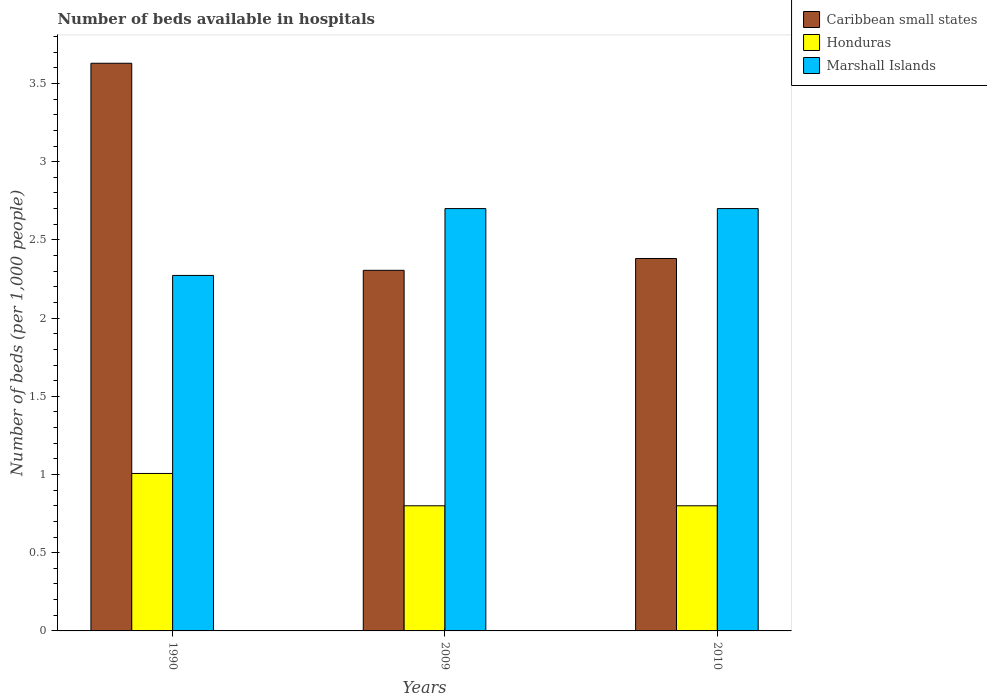How many different coloured bars are there?
Provide a short and direct response. 3. Are the number of bars per tick equal to the number of legend labels?
Offer a very short reply. Yes. How many bars are there on the 2nd tick from the left?
Keep it short and to the point. 3. How many bars are there on the 2nd tick from the right?
Offer a very short reply. 3. What is the label of the 1st group of bars from the left?
Make the answer very short. 1990. What is the number of beds in the hospiatls of in Honduras in 2010?
Give a very brief answer. 0.8. Across all years, what is the maximum number of beds in the hospiatls of in Marshall Islands?
Offer a very short reply. 2.7. Across all years, what is the minimum number of beds in the hospiatls of in Marshall Islands?
Keep it short and to the point. 2.27. What is the total number of beds in the hospiatls of in Marshall Islands in the graph?
Give a very brief answer. 7.67. What is the difference between the number of beds in the hospiatls of in Marshall Islands in 1990 and that in 2010?
Provide a short and direct response. -0.43. What is the difference between the number of beds in the hospiatls of in Marshall Islands in 2010 and the number of beds in the hospiatls of in Honduras in 2009?
Provide a succinct answer. 1.9. What is the average number of beds in the hospiatls of in Caribbean small states per year?
Keep it short and to the point. 2.77. In the year 1990, what is the difference between the number of beds in the hospiatls of in Marshall Islands and number of beds in the hospiatls of in Honduras?
Offer a terse response. 1.27. In how many years, is the number of beds in the hospiatls of in Marshall Islands greater than 0.7?
Your answer should be compact. 3. What is the ratio of the number of beds in the hospiatls of in Caribbean small states in 2009 to that in 2010?
Provide a succinct answer. 0.97. Is the number of beds in the hospiatls of in Marshall Islands in 1990 less than that in 2009?
Your answer should be very brief. Yes. Is the difference between the number of beds in the hospiatls of in Marshall Islands in 1990 and 2010 greater than the difference between the number of beds in the hospiatls of in Honduras in 1990 and 2010?
Give a very brief answer. No. What is the difference between the highest and the lowest number of beds in the hospiatls of in Caribbean small states?
Your response must be concise. 1.32. What does the 3rd bar from the left in 2010 represents?
Ensure brevity in your answer.  Marshall Islands. What does the 1st bar from the right in 2010 represents?
Your response must be concise. Marshall Islands. What is the difference between two consecutive major ticks on the Y-axis?
Ensure brevity in your answer.  0.5. Does the graph contain any zero values?
Offer a very short reply. No. Does the graph contain grids?
Ensure brevity in your answer.  No. Where does the legend appear in the graph?
Make the answer very short. Top right. How are the legend labels stacked?
Provide a short and direct response. Vertical. What is the title of the graph?
Make the answer very short. Number of beds available in hospitals. Does "Liberia" appear as one of the legend labels in the graph?
Give a very brief answer. No. What is the label or title of the Y-axis?
Provide a succinct answer. Number of beds (per 1,0 people). What is the Number of beds (per 1,000 people) in Caribbean small states in 1990?
Provide a succinct answer. 3.63. What is the Number of beds (per 1,000 people) of Honduras in 1990?
Provide a succinct answer. 1.01. What is the Number of beds (per 1,000 people) in Marshall Islands in 1990?
Provide a succinct answer. 2.27. What is the Number of beds (per 1,000 people) of Caribbean small states in 2009?
Your answer should be compact. 2.31. What is the Number of beds (per 1,000 people) of Honduras in 2009?
Your response must be concise. 0.8. What is the Number of beds (per 1,000 people) of Caribbean small states in 2010?
Offer a very short reply. 2.38. What is the Number of beds (per 1,000 people) of Honduras in 2010?
Make the answer very short. 0.8. What is the Number of beds (per 1,000 people) of Marshall Islands in 2010?
Your response must be concise. 2.7. Across all years, what is the maximum Number of beds (per 1,000 people) of Caribbean small states?
Ensure brevity in your answer.  3.63. Across all years, what is the maximum Number of beds (per 1,000 people) in Honduras?
Ensure brevity in your answer.  1.01. Across all years, what is the minimum Number of beds (per 1,000 people) in Caribbean small states?
Offer a terse response. 2.31. Across all years, what is the minimum Number of beds (per 1,000 people) of Marshall Islands?
Your answer should be compact. 2.27. What is the total Number of beds (per 1,000 people) of Caribbean small states in the graph?
Your response must be concise. 8.32. What is the total Number of beds (per 1,000 people) of Honduras in the graph?
Give a very brief answer. 2.61. What is the total Number of beds (per 1,000 people) of Marshall Islands in the graph?
Ensure brevity in your answer.  7.67. What is the difference between the Number of beds (per 1,000 people) in Caribbean small states in 1990 and that in 2009?
Your answer should be very brief. 1.32. What is the difference between the Number of beds (per 1,000 people) in Honduras in 1990 and that in 2009?
Make the answer very short. 0.21. What is the difference between the Number of beds (per 1,000 people) of Marshall Islands in 1990 and that in 2009?
Offer a very short reply. -0.43. What is the difference between the Number of beds (per 1,000 people) of Caribbean small states in 1990 and that in 2010?
Offer a very short reply. 1.25. What is the difference between the Number of beds (per 1,000 people) of Honduras in 1990 and that in 2010?
Make the answer very short. 0.21. What is the difference between the Number of beds (per 1,000 people) in Marshall Islands in 1990 and that in 2010?
Ensure brevity in your answer.  -0.43. What is the difference between the Number of beds (per 1,000 people) of Caribbean small states in 2009 and that in 2010?
Provide a short and direct response. -0.08. What is the difference between the Number of beds (per 1,000 people) of Caribbean small states in 1990 and the Number of beds (per 1,000 people) of Honduras in 2009?
Your answer should be very brief. 2.83. What is the difference between the Number of beds (per 1,000 people) in Caribbean small states in 1990 and the Number of beds (per 1,000 people) in Marshall Islands in 2009?
Your answer should be compact. 0.93. What is the difference between the Number of beds (per 1,000 people) in Honduras in 1990 and the Number of beds (per 1,000 people) in Marshall Islands in 2009?
Offer a very short reply. -1.69. What is the difference between the Number of beds (per 1,000 people) in Caribbean small states in 1990 and the Number of beds (per 1,000 people) in Honduras in 2010?
Your answer should be very brief. 2.83. What is the difference between the Number of beds (per 1,000 people) of Caribbean small states in 1990 and the Number of beds (per 1,000 people) of Marshall Islands in 2010?
Your response must be concise. 0.93. What is the difference between the Number of beds (per 1,000 people) in Honduras in 1990 and the Number of beds (per 1,000 people) in Marshall Islands in 2010?
Give a very brief answer. -1.69. What is the difference between the Number of beds (per 1,000 people) in Caribbean small states in 2009 and the Number of beds (per 1,000 people) in Honduras in 2010?
Your answer should be compact. 1.51. What is the difference between the Number of beds (per 1,000 people) of Caribbean small states in 2009 and the Number of beds (per 1,000 people) of Marshall Islands in 2010?
Provide a short and direct response. -0.39. What is the difference between the Number of beds (per 1,000 people) of Honduras in 2009 and the Number of beds (per 1,000 people) of Marshall Islands in 2010?
Provide a short and direct response. -1.9. What is the average Number of beds (per 1,000 people) of Caribbean small states per year?
Offer a terse response. 2.77. What is the average Number of beds (per 1,000 people) of Honduras per year?
Offer a very short reply. 0.87. What is the average Number of beds (per 1,000 people) of Marshall Islands per year?
Your answer should be compact. 2.56. In the year 1990, what is the difference between the Number of beds (per 1,000 people) of Caribbean small states and Number of beds (per 1,000 people) of Honduras?
Your answer should be compact. 2.62. In the year 1990, what is the difference between the Number of beds (per 1,000 people) of Caribbean small states and Number of beds (per 1,000 people) of Marshall Islands?
Your response must be concise. 1.36. In the year 1990, what is the difference between the Number of beds (per 1,000 people) of Honduras and Number of beds (per 1,000 people) of Marshall Islands?
Offer a very short reply. -1.27. In the year 2009, what is the difference between the Number of beds (per 1,000 people) in Caribbean small states and Number of beds (per 1,000 people) in Honduras?
Your answer should be very brief. 1.51. In the year 2009, what is the difference between the Number of beds (per 1,000 people) of Caribbean small states and Number of beds (per 1,000 people) of Marshall Islands?
Give a very brief answer. -0.39. In the year 2009, what is the difference between the Number of beds (per 1,000 people) in Honduras and Number of beds (per 1,000 people) in Marshall Islands?
Offer a very short reply. -1.9. In the year 2010, what is the difference between the Number of beds (per 1,000 people) in Caribbean small states and Number of beds (per 1,000 people) in Honduras?
Offer a very short reply. 1.58. In the year 2010, what is the difference between the Number of beds (per 1,000 people) in Caribbean small states and Number of beds (per 1,000 people) in Marshall Islands?
Make the answer very short. -0.32. What is the ratio of the Number of beds (per 1,000 people) of Caribbean small states in 1990 to that in 2009?
Offer a terse response. 1.57. What is the ratio of the Number of beds (per 1,000 people) of Honduras in 1990 to that in 2009?
Make the answer very short. 1.26. What is the ratio of the Number of beds (per 1,000 people) of Marshall Islands in 1990 to that in 2009?
Provide a succinct answer. 0.84. What is the ratio of the Number of beds (per 1,000 people) of Caribbean small states in 1990 to that in 2010?
Give a very brief answer. 1.52. What is the ratio of the Number of beds (per 1,000 people) of Honduras in 1990 to that in 2010?
Provide a short and direct response. 1.26. What is the ratio of the Number of beds (per 1,000 people) of Marshall Islands in 1990 to that in 2010?
Your answer should be very brief. 0.84. What is the ratio of the Number of beds (per 1,000 people) in Caribbean small states in 2009 to that in 2010?
Your answer should be very brief. 0.97. What is the ratio of the Number of beds (per 1,000 people) in Honduras in 2009 to that in 2010?
Your answer should be compact. 1. What is the ratio of the Number of beds (per 1,000 people) of Marshall Islands in 2009 to that in 2010?
Offer a very short reply. 1. What is the difference between the highest and the second highest Number of beds (per 1,000 people) of Caribbean small states?
Provide a succinct answer. 1.25. What is the difference between the highest and the second highest Number of beds (per 1,000 people) in Honduras?
Provide a succinct answer. 0.21. What is the difference between the highest and the lowest Number of beds (per 1,000 people) in Caribbean small states?
Provide a succinct answer. 1.32. What is the difference between the highest and the lowest Number of beds (per 1,000 people) of Honduras?
Make the answer very short. 0.21. What is the difference between the highest and the lowest Number of beds (per 1,000 people) in Marshall Islands?
Offer a terse response. 0.43. 